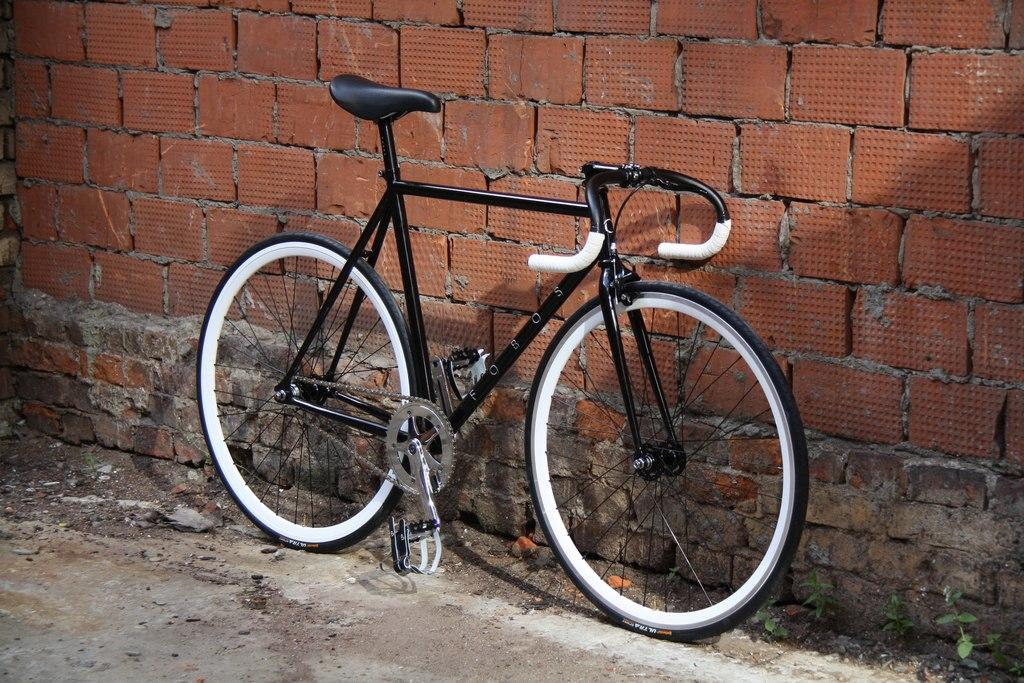What is the main object in the picture? There is a bicycle in the picture. What is written or displayed on the bicycle? There is text on the bicycle. What can be seen in the background of the picture? There is a wall in the background of the picture. What type of vegetation is present on the ground in the picture? There are plants on the ground in the picture. Where is the faucet located in the picture? There is no faucet present in the picture. What is the height of the grass in the picture? There is no grass present in the picture; it features plants on the ground. 